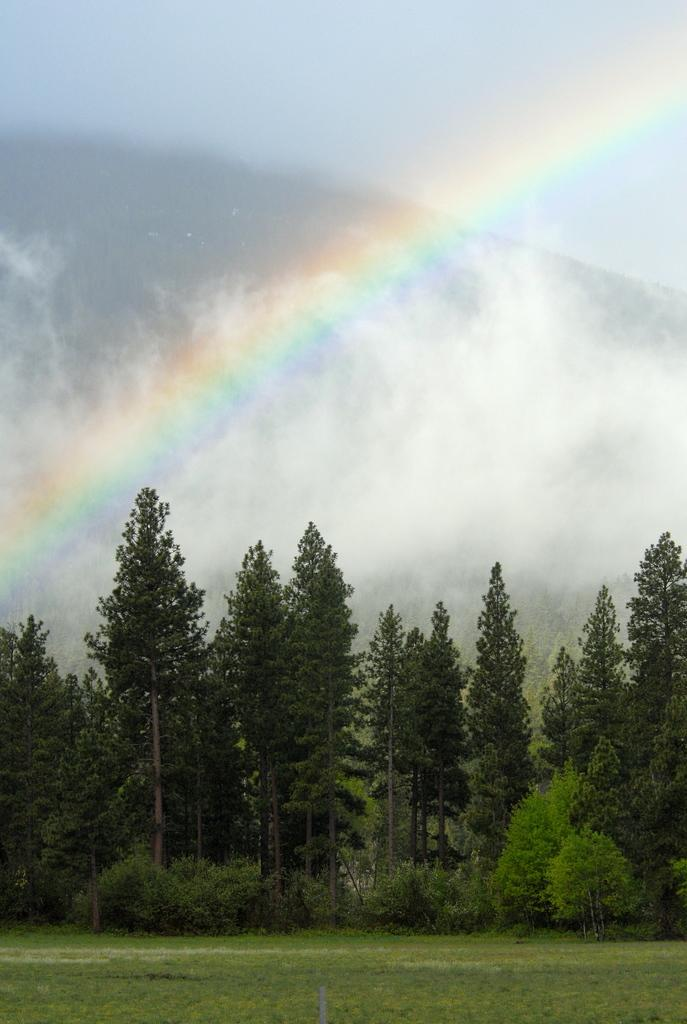What type of surface is visible in the image? There is a grass surface in the image. What can be seen in the background of the image? Plants and trees are visible in the background of the image. What is present in the sky in the image? There is a rainbow in the sky in the image. Where is the robin delivering the parcel in the image? There is no robin or parcel present in the image. What type of garden is visible in the image? There is no garden visible in the image; it features a grass surface and a background with plants and trees. 